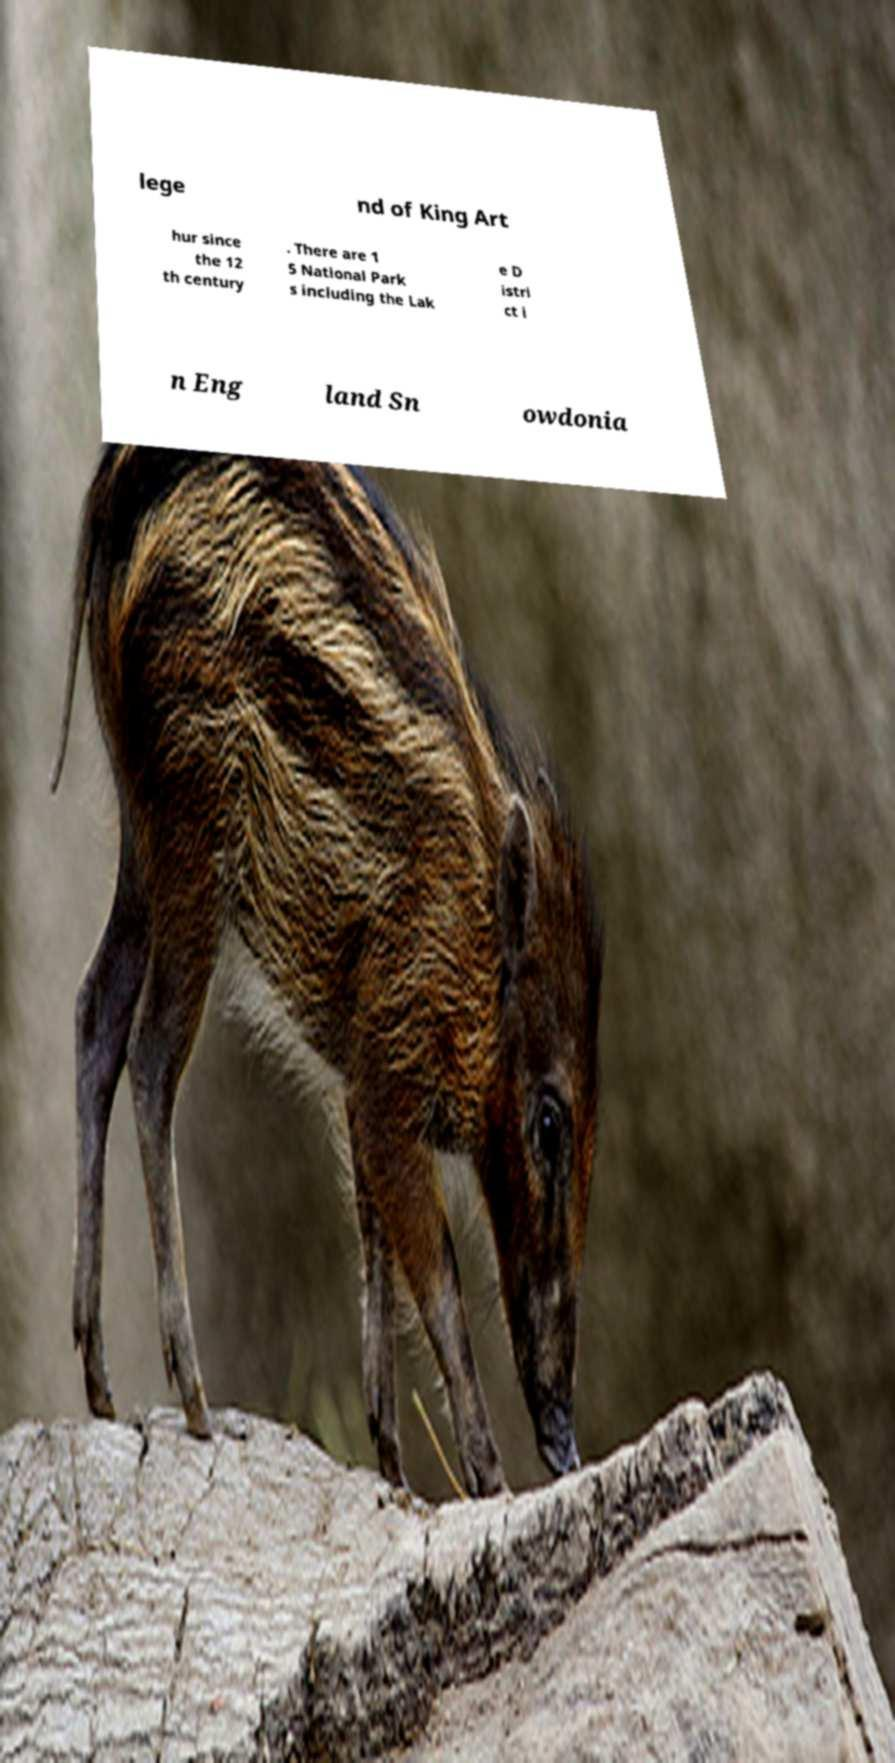Could you assist in decoding the text presented in this image and type it out clearly? lege nd of King Art hur since the 12 th century . There are 1 5 National Park s including the Lak e D istri ct i n Eng land Sn owdonia 